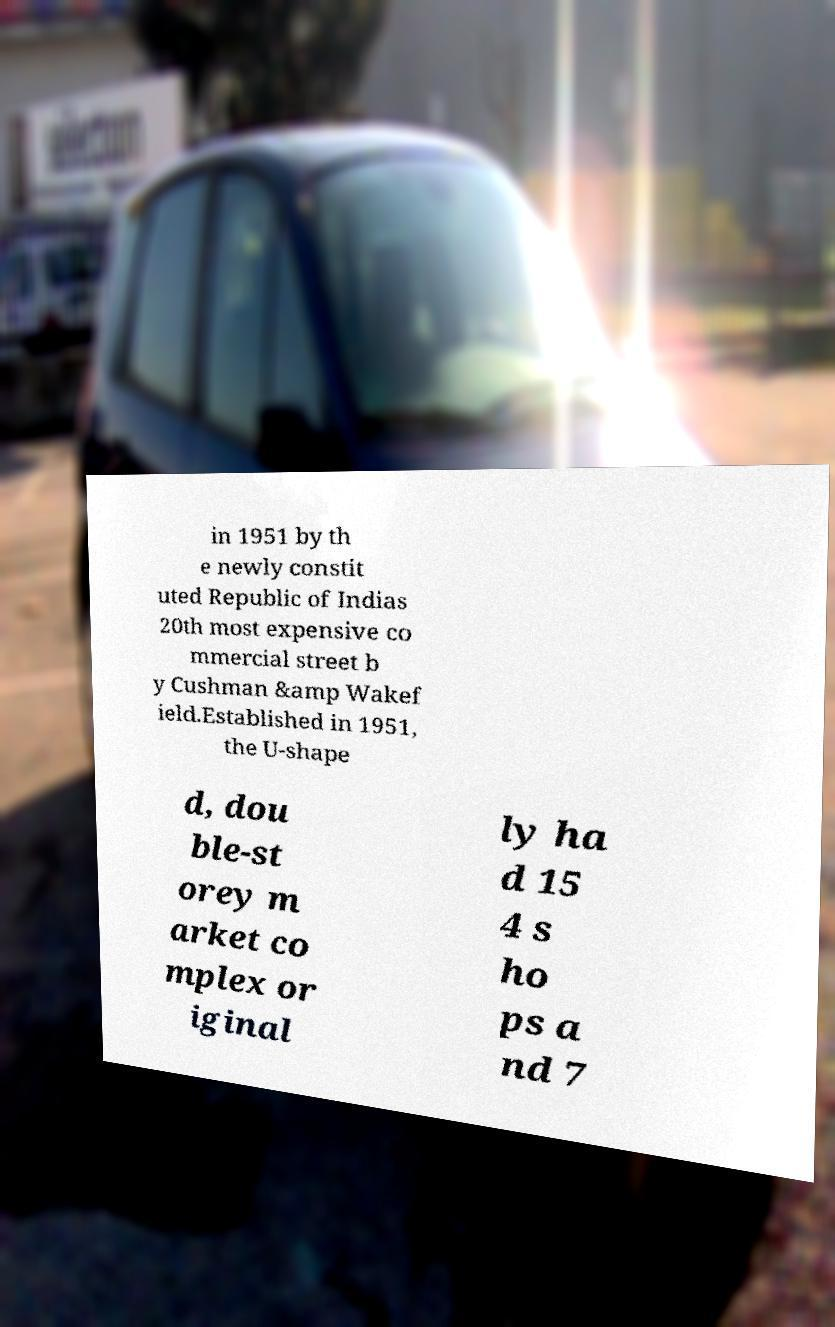Can you read and provide the text displayed in the image?This photo seems to have some interesting text. Can you extract and type it out for me? in 1951 by th e newly constit uted Republic of Indias 20th most expensive co mmercial street b y Cushman &amp Wakef ield.Established in 1951, the U-shape d, dou ble-st orey m arket co mplex or iginal ly ha d 15 4 s ho ps a nd 7 